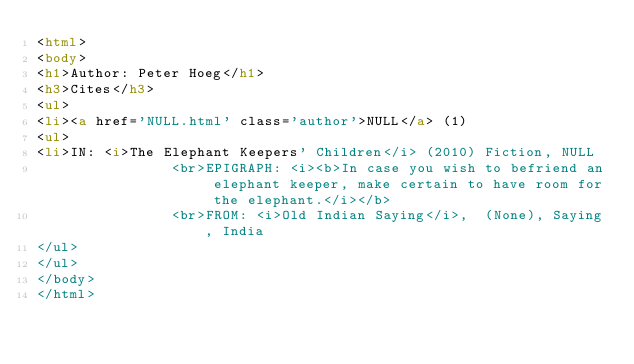Convert code to text. <code><loc_0><loc_0><loc_500><loc_500><_HTML_><html>
<body>
<h1>Author: Peter Hoeg</h1>
<h3>Cites</h3>
<ul>
<li><a href='NULL.html' class='author'>NULL</a> (1)
<ul>
<li>IN: <i>The Elephant Keepers' Children</i> (2010) Fiction, NULL
                <br>EPIGRAPH: <i><b>In case you wish to befriend an elephant keeper, make certain to have room for the elephant.</i></b>
                <br>FROM: <i>Old Indian Saying</i>,  (None), Saying, India
</ul>
</ul>
</body>
</html>
</code> 